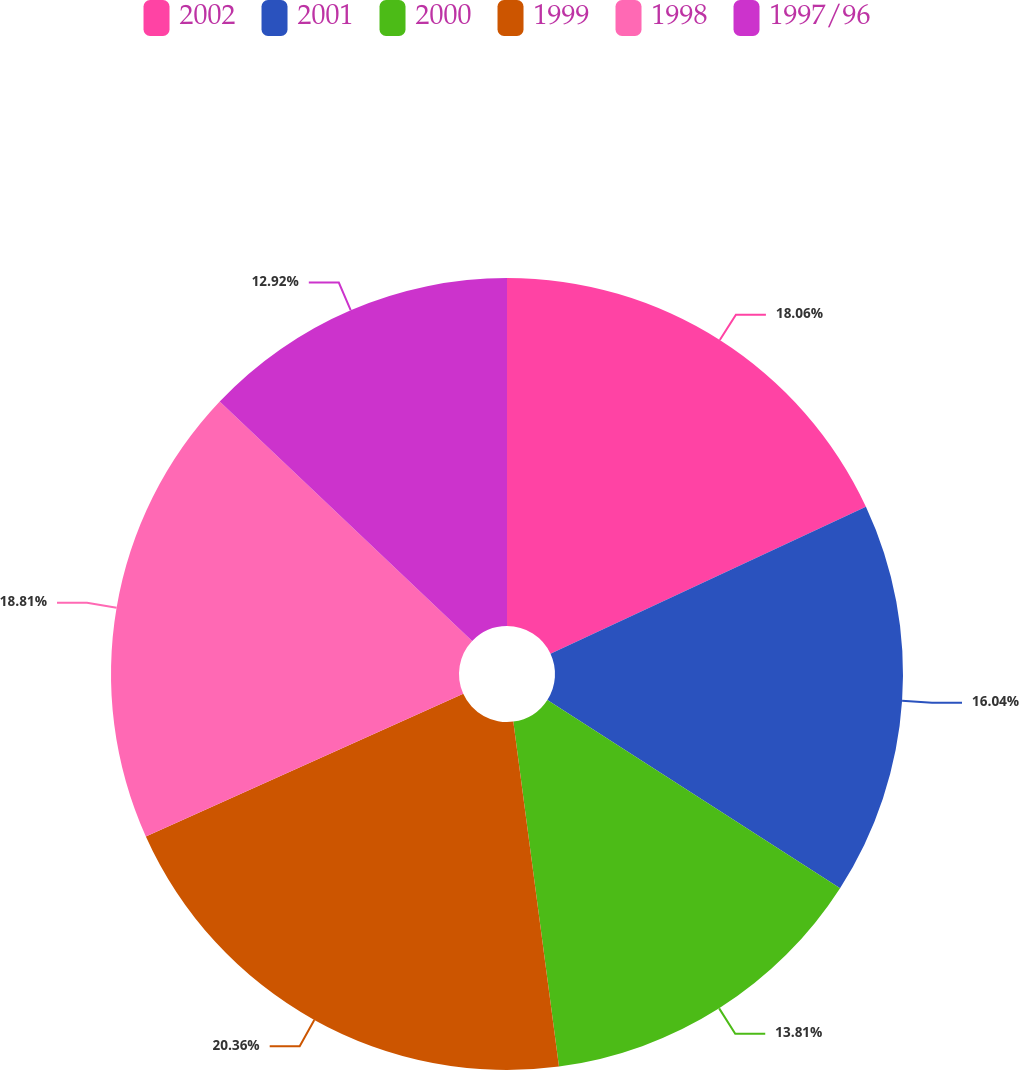Convert chart to OTSL. <chart><loc_0><loc_0><loc_500><loc_500><pie_chart><fcel>2002<fcel>2001<fcel>2000<fcel>1999<fcel>1998<fcel>1997/96<nl><fcel>18.06%<fcel>16.04%<fcel>13.81%<fcel>20.37%<fcel>18.81%<fcel>12.92%<nl></chart> 